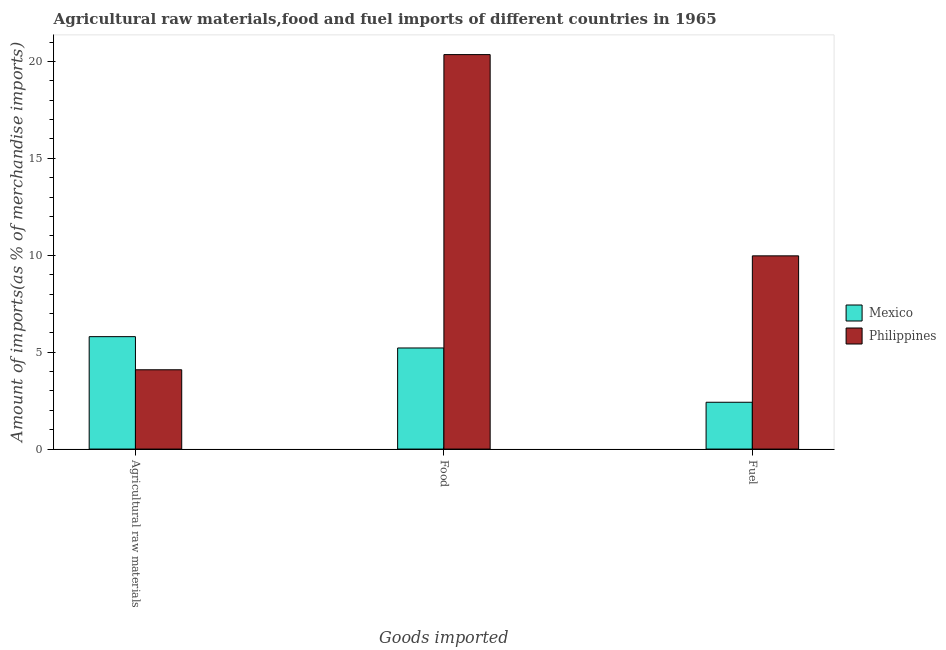How many different coloured bars are there?
Keep it short and to the point. 2. How many bars are there on the 3rd tick from the right?
Your answer should be compact. 2. What is the label of the 2nd group of bars from the left?
Give a very brief answer. Food. What is the percentage of fuel imports in Philippines?
Offer a very short reply. 9.97. Across all countries, what is the maximum percentage of fuel imports?
Offer a very short reply. 9.97. Across all countries, what is the minimum percentage of raw materials imports?
Keep it short and to the point. 4.09. In which country was the percentage of raw materials imports minimum?
Make the answer very short. Philippines. What is the total percentage of fuel imports in the graph?
Your response must be concise. 12.39. What is the difference between the percentage of food imports in Mexico and that in Philippines?
Offer a very short reply. -15.14. What is the difference between the percentage of raw materials imports in Mexico and the percentage of food imports in Philippines?
Provide a short and direct response. -14.55. What is the average percentage of raw materials imports per country?
Your response must be concise. 4.95. What is the difference between the percentage of food imports and percentage of fuel imports in Philippines?
Provide a short and direct response. 10.38. What is the ratio of the percentage of raw materials imports in Mexico to that in Philippines?
Ensure brevity in your answer.  1.42. Is the percentage of food imports in Mexico less than that in Philippines?
Offer a very short reply. Yes. Is the difference between the percentage of food imports in Mexico and Philippines greater than the difference between the percentage of fuel imports in Mexico and Philippines?
Offer a terse response. No. What is the difference between the highest and the second highest percentage of food imports?
Ensure brevity in your answer.  15.14. What is the difference between the highest and the lowest percentage of fuel imports?
Keep it short and to the point. 7.55. In how many countries, is the percentage of fuel imports greater than the average percentage of fuel imports taken over all countries?
Your answer should be compact. 1. What does the 1st bar from the left in Food represents?
Provide a succinct answer. Mexico. What does the 2nd bar from the right in Agricultural raw materials represents?
Your answer should be compact. Mexico. How many bars are there?
Offer a very short reply. 6. What is the difference between two consecutive major ticks on the Y-axis?
Offer a very short reply. 5. Does the graph contain any zero values?
Make the answer very short. No. Does the graph contain grids?
Make the answer very short. No. What is the title of the graph?
Your response must be concise. Agricultural raw materials,food and fuel imports of different countries in 1965. Does "Iceland" appear as one of the legend labels in the graph?
Your answer should be compact. No. What is the label or title of the X-axis?
Ensure brevity in your answer.  Goods imported. What is the label or title of the Y-axis?
Your answer should be compact. Amount of imports(as % of merchandise imports). What is the Amount of imports(as % of merchandise imports) in Mexico in Agricultural raw materials?
Offer a terse response. 5.8. What is the Amount of imports(as % of merchandise imports) of Philippines in Agricultural raw materials?
Your answer should be compact. 4.09. What is the Amount of imports(as % of merchandise imports) in Mexico in Food?
Make the answer very short. 5.22. What is the Amount of imports(as % of merchandise imports) of Philippines in Food?
Provide a succinct answer. 20.35. What is the Amount of imports(as % of merchandise imports) in Mexico in Fuel?
Keep it short and to the point. 2.42. What is the Amount of imports(as % of merchandise imports) of Philippines in Fuel?
Your answer should be very brief. 9.97. Across all Goods imported, what is the maximum Amount of imports(as % of merchandise imports) of Mexico?
Offer a very short reply. 5.8. Across all Goods imported, what is the maximum Amount of imports(as % of merchandise imports) in Philippines?
Provide a succinct answer. 20.35. Across all Goods imported, what is the minimum Amount of imports(as % of merchandise imports) of Mexico?
Provide a short and direct response. 2.42. Across all Goods imported, what is the minimum Amount of imports(as % of merchandise imports) in Philippines?
Offer a very short reply. 4.09. What is the total Amount of imports(as % of merchandise imports) in Mexico in the graph?
Your answer should be very brief. 13.43. What is the total Amount of imports(as % of merchandise imports) of Philippines in the graph?
Make the answer very short. 34.42. What is the difference between the Amount of imports(as % of merchandise imports) in Mexico in Agricultural raw materials and that in Food?
Your answer should be very brief. 0.58. What is the difference between the Amount of imports(as % of merchandise imports) in Philippines in Agricultural raw materials and that in Food?
Your answer should be very brief. -16.26. What is the difference between the Amount of imports(as % of merchandise imports) of Mexico in Agricultural raw materials and that in Fuel?
Provide a succinct answer. 3.39. What is the difference between the Amount of imports(as % of merchandise imports) of Philippines in Agricultural raw materials and that in Fuel?
Provide a succinct answer. -5.88. What is the difference between the Amount of imports(as % of merchandise imports) in Mexico in Food and that in Fuel?
Your answer should be very brief. 2.8. What is the difference between the Amount of imports(as % of merchandise imports) of Philippines in Food and that in Fuel?
Offer a very short reply. 10.38. What is the difference between the Amount of imports(as % of merchandise imports) in Mexico in Agricultural raw materials and the Amount of imports(as % of merchandise imports) in Philippines in Food?
Keep it short and to the point. -14.55. What is the difference between the Amount of imports(as % of merchandise imports) of Mexico in Agricultural raw materials and the Amount of imports(as % of merchandise imports) of Philippines in Fuel?
Offer a very short reply. -4.17. What is the difference between the Amount of imports(as % of merchandise imports) in Mexico in Food and the Amount of imports(as % of merchandise imports) in Philippines in Fuel?
Keep it short and to the point. -4.75. What is the average Amount of imports(as % of merchandise imports) in Mexico per Goods imported?
Your answer should be compact. 4.48. What is the average Amount of imports(as % of merchandise imports) in Philippines per Goods imported?
Give a very brief answer. 11.47. What is the difference between the Amount of imports(as % of merchandise imports) of Mexico and Amount of imports(as % of merchandise imports) of Philippines in Agricultural raw materials?
Offer a terse response. 1.71. What is the difference between the Amount of imports(as % of merchandise imports) of Mexico and Amount of imports(as % of merchandise imports) of Philippines in Food?
Your answer should be very brief. -15.14. What is the difference between the Amount of imports(as % of merchandise imports) in Mexico and Amount of imports(as % of merchandise imports) in Philippines in Fuel?
Offer a very short reply. -7.55. What is the ratio of the Amount of imports(as % of merchandise imports) in Mexico in Agricultural raw materials to that in Food?
Your answer should be compact. 1.11. What is the ratio of the Amount of imports(as % of merchandise imports) in Philippines in Agricultural raw materials to that in Food?
Keep it short and to the point. 0.2. What is the ratio of the Amount of imports(as % of merchandise imports) in Mexico in Agricultural raw materials to that in Fuel?
Provide a succinct answer. 2.4. What is the ratio of the Amount of imports(as % of merchandise imports) of Philippines in Agricultural raw materials to that in Fuel?
Offer a terse response. 0.41. What is the ratio of the Amount of imports(as % of merchandise imports) in Mexico in Food to that in Fuel?
Your response must be concise. 2.16. What is the ratio of the Amount of imports(as % of merchandise imports) of Philippines in Food to that in Fuel?
Your response must be concise. 2.04. What is the difference between the highest and the second highest Amount of imports(as % of merchandise imports) in Mexico?
Your response must be concise. 0.58. What is the difference between the highest and the second highest Amount of imports(as % of merchandise imports) in Philippines?
Offer a terse response. 10.38. What is the difference between the highest and the lowest Amount of imports(as % of merchandise imports) in Mexico?
Ensure brevity in your answer.  3.39. What is the difference between the highest and the lowest Amount of imports(as % of merchandise imports) of Philippines?
Keep it short and to the point. 16.26. 